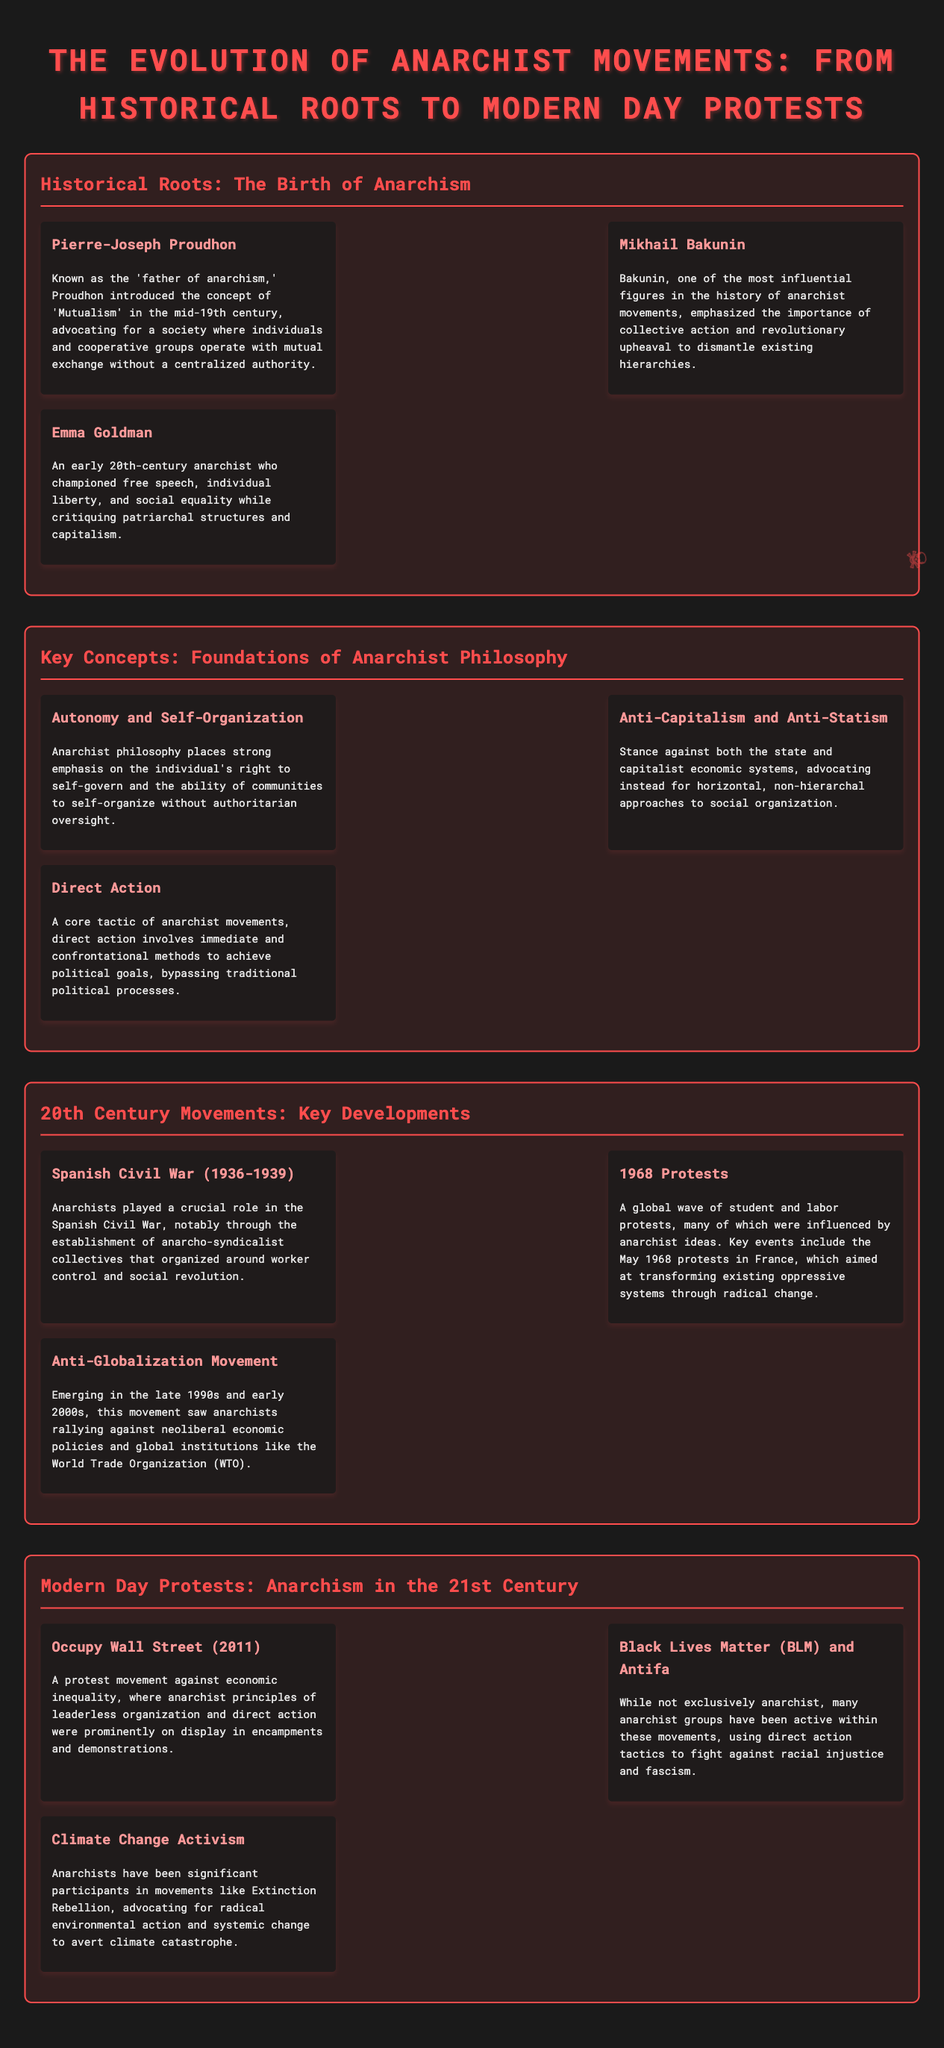What is the title of the document? The title of the document is given at the top of the infographic.
Answer: The Evolution of Anarchist Movements: From Historical Roots to Modern Day Protests Who is known as the 'father of anarchism'? This is a specific information retrieval question about a notable figure mentioned in the document.
Answer: Pierre-Joseph Proudhon What concept did Mikhail Bakunin emphasize? This question targets understanding Bakunin's key contribution to anarchist philosophy from the document.
Answer: Collective action Which war involved anarchists in a significant role during the 20th century? This refers to a specific historical event discussed in the document that highlights anarchist involvement.
Answer: Spanish Civil War What year did Occupy Wall Street begin? This numeric retrieval question asks for a specific date related to a modern protest movement mentioned in the document.
Answer: 2011 What philosophy does anarchism strongly emphasize? This question requires synthesis of core beliefs detailed in the document regarding anarchist ideology.
Answer: Autonomy and Self-Organization Which two modern movements are associated with anarchist principles? This question encompasses a comparison of more than one modern protest movement indicated in the document.
Answer: Black Lives Matter and Antifa What tactical approach do anarchists advocate for achieving political goals? This question focuses on the strategies discussed in the document related to anarchist actions.
Answer: Direct Action 